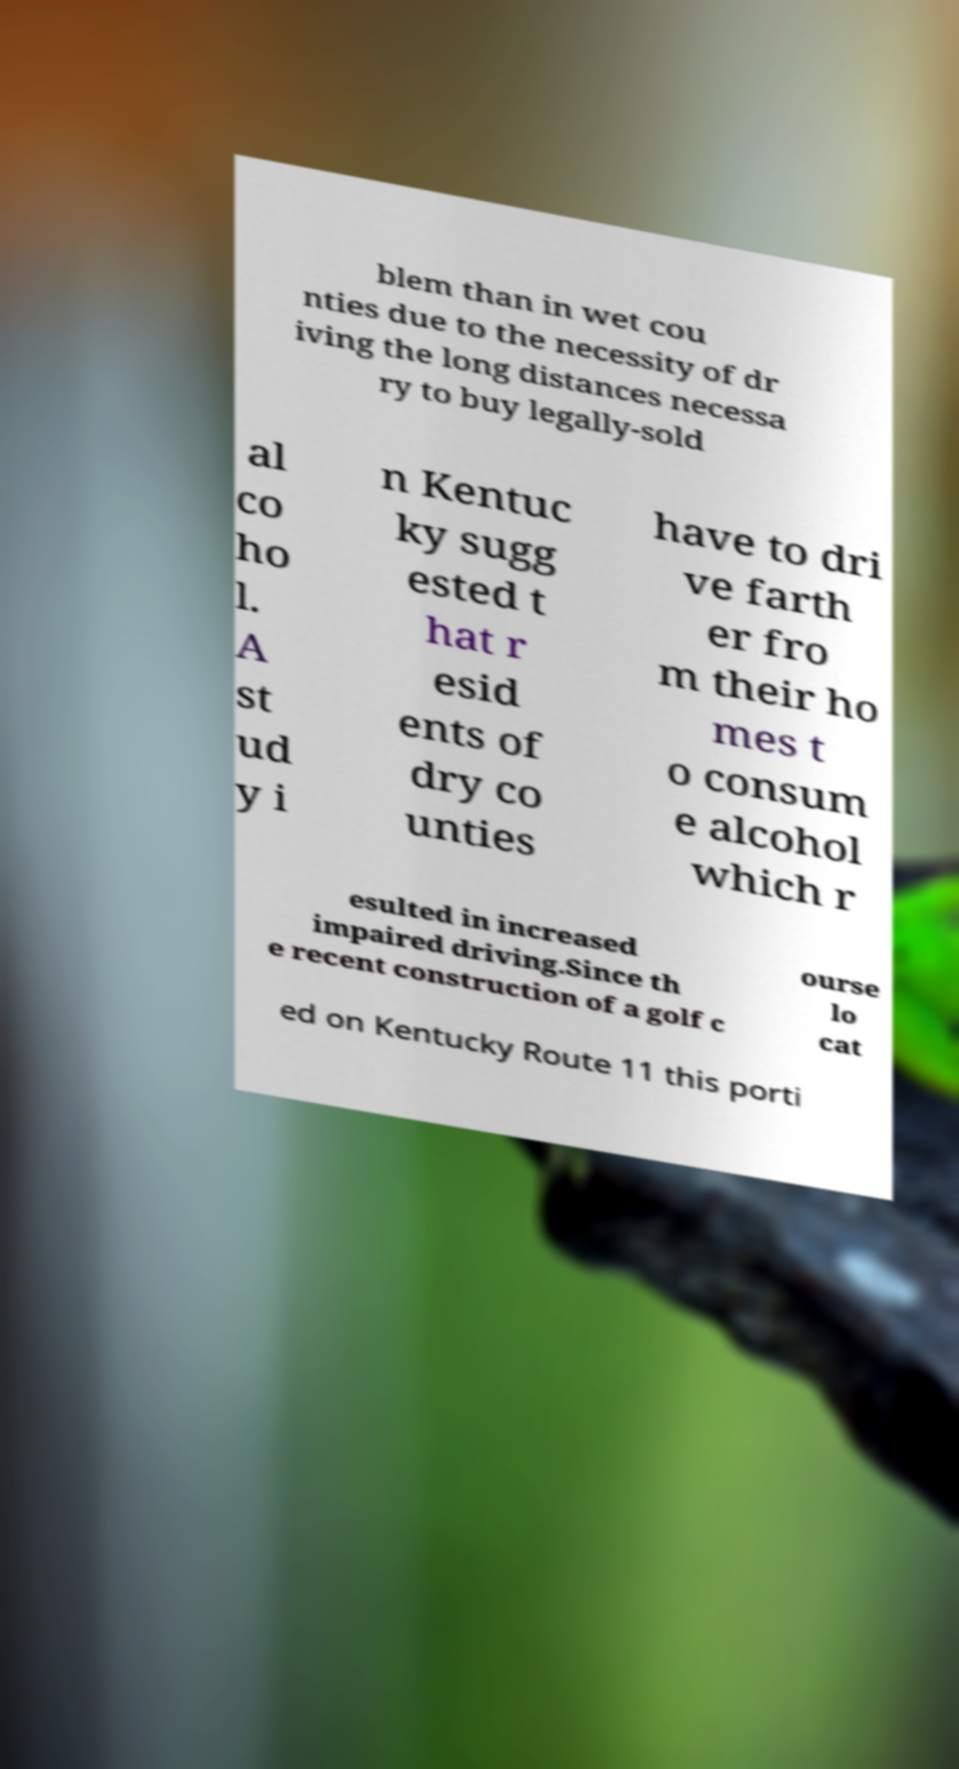What messages or text are displayed in this image? I need them in a readable, typed format. blem than in wet cou nties due to the necessity of dr iving the long distances necessa ry to buy legally-sold al co ho l. A st ud y i n Kentuc ky sugg ested t hat r esid ents of dry co unties have to dri ve farth er fro m their ho mes t o consum e alcohol which r esulted in increased impaired driving.Since th e recent construction of a golf c ourse lo cat ed on Kentucky Route 11 this porti 